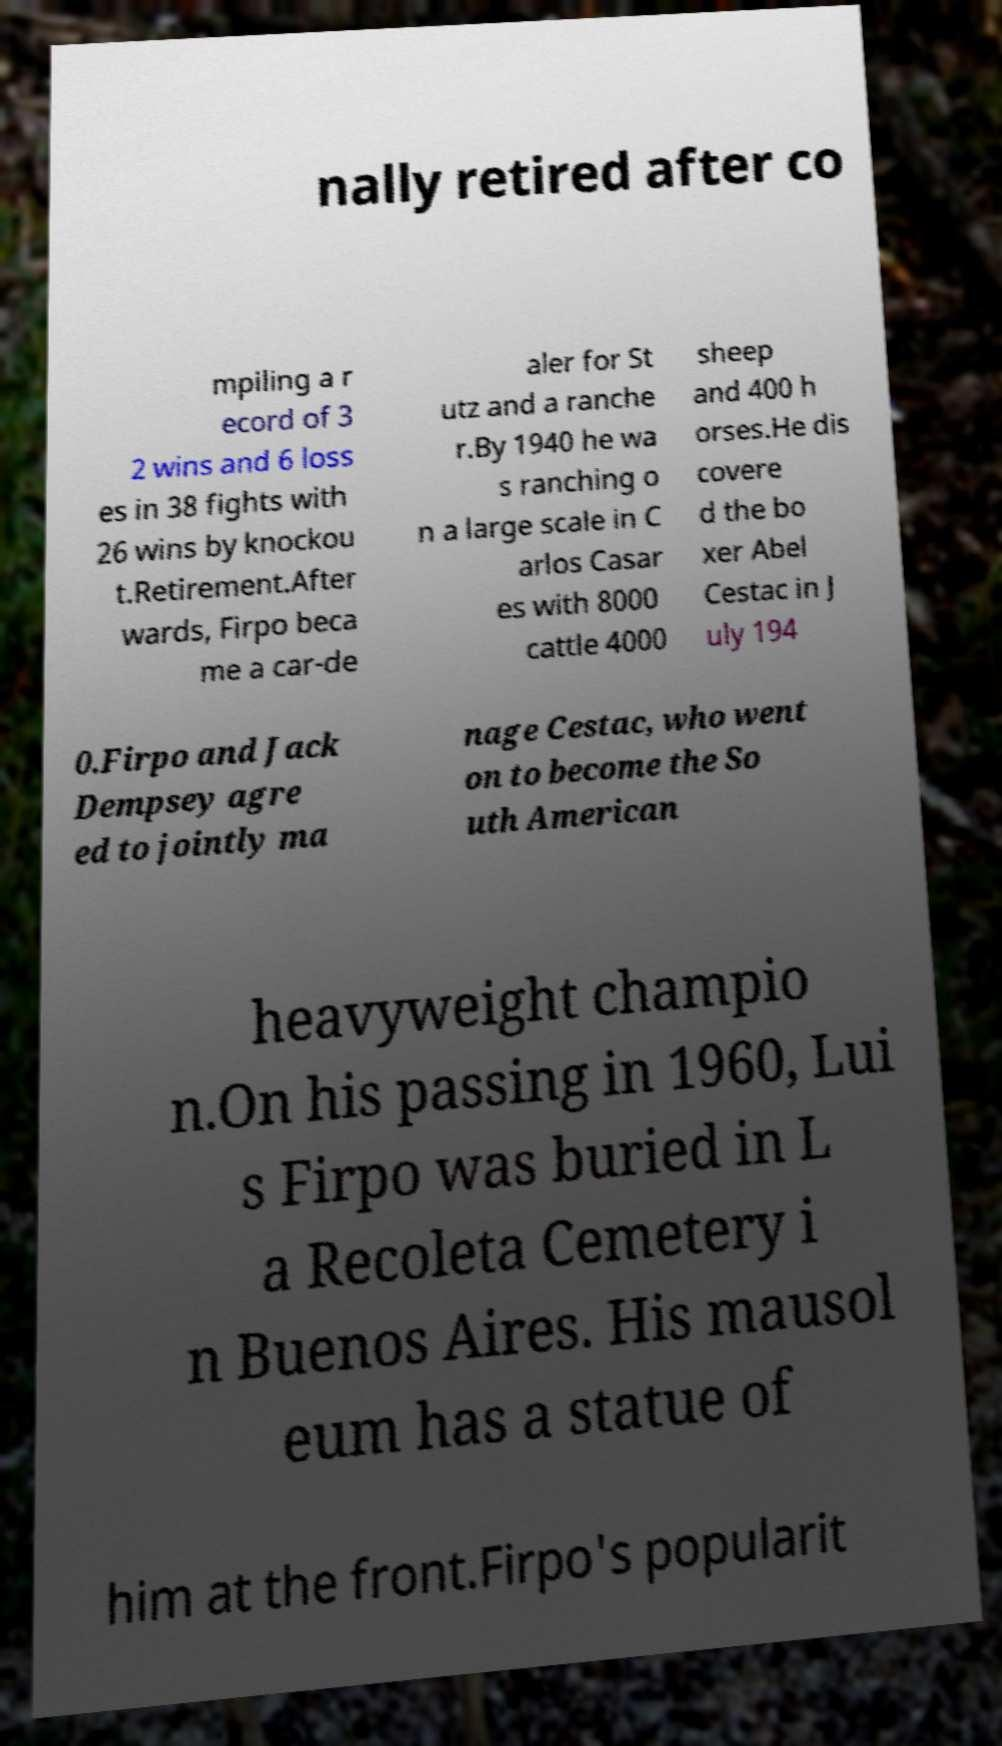There's text embedded in this image that I need extracted. Can you transcribe it verbatim? nally retired after co mpiling a r ecord of 3 2 wins and 6 loss es in 38 fights with 26 wins by knockou t.Retirement.After wards, Firpo beca me a car-de aler for St utz and a ranche r.By 1940 he wa s ranching o n a large scale in C arlos Casar es with 8000 cattle 4000 sheep and 400 h orses.He dis covere d the bo xer Abel Cestac in J uly 194 0.Firpo and Jack Dempsey agre ed to jointly ma nage Cestac, who went on to become the So uth American heavyweight champio n.On his passing in 1960, Lui s Firpo was buried in L a Recoleta Cemetery i n Buenos Aires. His mausol eum has a statue of him at the front.Firpo's popularit 